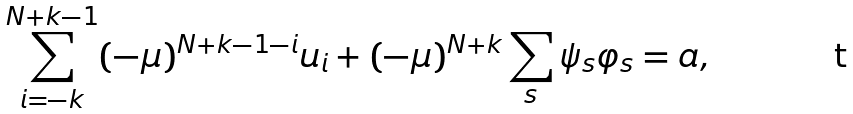Convert formula to latex. <formula><loc_0><loc_0><loc_500><loc_500>\sum _ { i = - k } ^ { N + k - 1 } ( - \mu ) ^ { N + k - 1 - i } u _ { i } + ( - \mu ) ^ { N + k } \sum _ { s } \psi _ { s } \varphi _ { s } = a ,</formula> 